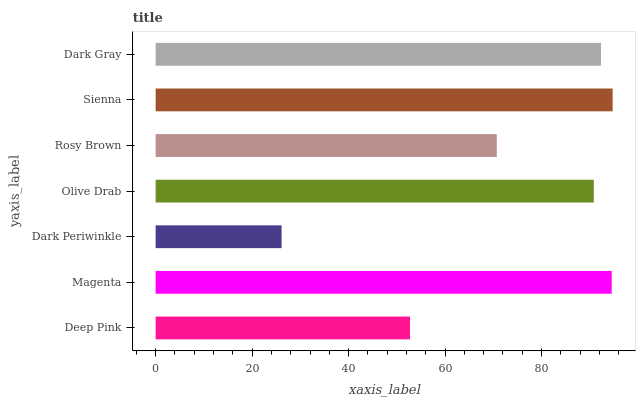Is Dark Periwinkle the minimum?
Answer yes or no. Yes. Is Sienna the maximum?
Answer yes or no. Yes. Is Magenta the minimum?
Answer yes or no. No. Is Magenta the maximum?
Answer yes or no. No. Is Magenta greater than Deep Pink?
Answer yes or no. Yes. Is Deep Pink less than Magenta?
Answer yes or no. Yes. Is Deep Pink greater than Magenta?
Answer yes or no. No. Is Magenta less than Deep Pink?
Answer yes or no. No. Is Olive Drab the high median?
Answer yes or no. Yes. Is Olive Drab the low median?
Answer yes or no. Yes. Is Sienna the high median?
Answer yes or no. No. Is Sienna the low median?
Answer yes or no. No. 